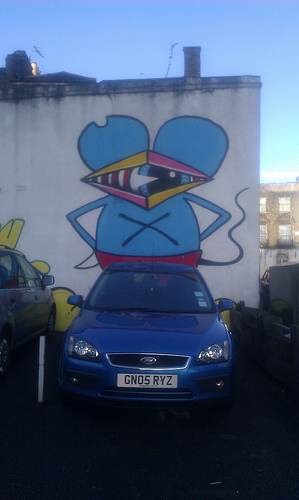<image>
Is there a illustration above the car? Yes. The illustration is positioned above the car in the vertical space, higher up in the scene. 